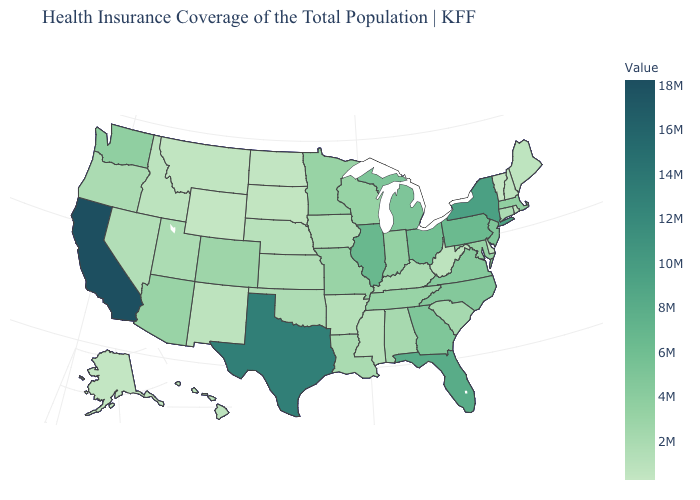Does the map have missing data?
Keep it brief. No. Among the states that border Kansas , does Colorado have the lowest value?
Be succinct. No. Among the states that border Minnesota , which have the lowest value?
Give a very brief answer. North Dakota. Among the states that border Arkansas , does Missouri have the highest value?
Quick response, please. No. Does Connecticut have a lower value than Michigan?
Answer briefly. Yes. Which states have the lowest value in the MidWest?
Quick response, please. North Dakota. Among the states that border North Dakota , does Minnesota have the highest value?
Write a very short answer. Yes. 